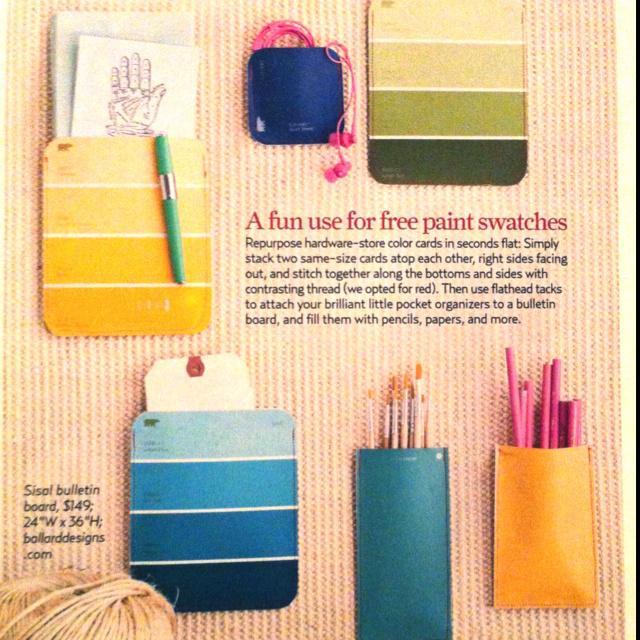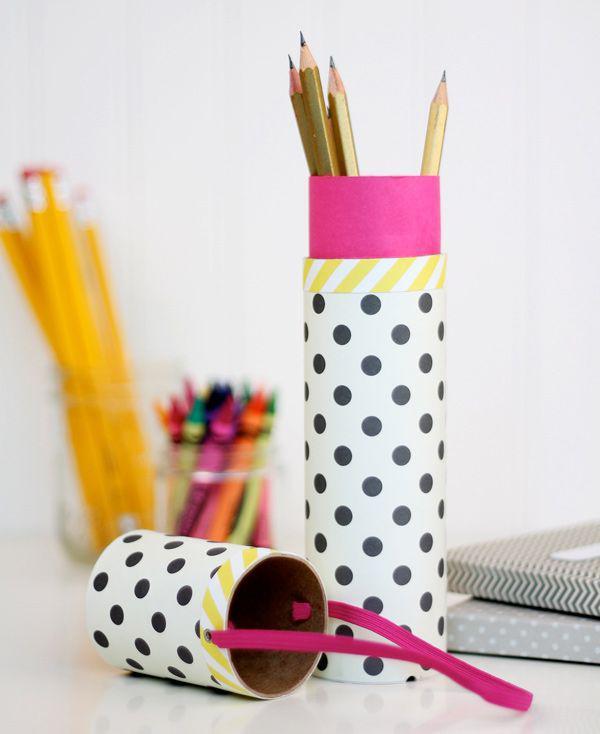The first image is the image on the left, the second image is the image on the right. For the images shown, is this caption "There are no writing utensils visible in one of the pictures." true? Answer yes or no. No. The first image is the image on the left, the second image is the image on the right. For the images shown, is this caption "there are pencils with the erasers side up" true? Answer yes or no. Yes. 